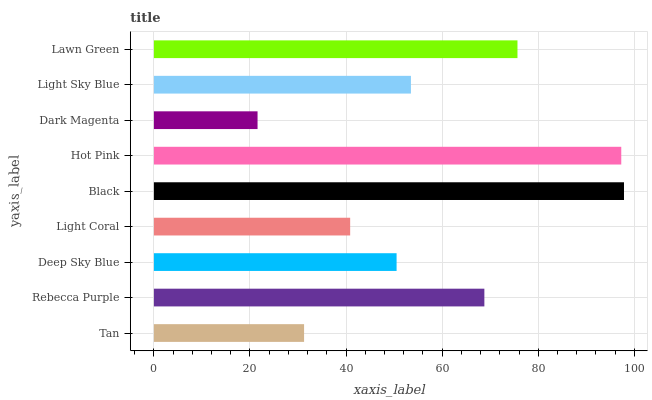Is Dark Magenta the minimum?
Answer yes or no. Yes. Is Black the maximum?
Answer yes or no. Yes. Is Rebecca Purple the minimum?
Answer yes or no. No. Is Rebecca Purple the maximum?
Answer yes or no. No. Is Rebecca Purple greater than Tan?
Answer yes or no. Yes. Is Tan less than Rebecca Purple?
Answer yes or no. Yes. Is Tan greater than Rebecca Purple?
Answer yes or no. No. Is Rebecca Purple less than Tan?
Answer yes or no. No. Is Light Sky Blue the high median?
Answer yes or no. Yes. Is Light Sky Blue the low median?
Answer yes or no. Yes. Is Deep Sky Blue the high median?
Answer yes or no. No. Is Dark Magenta the low median?
Answer yes or no. No. 